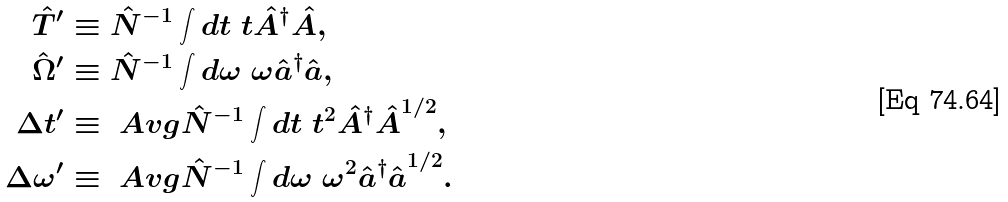<formula> <loc_0><loc_0><loc_500><loc_500>\hat { T } ^ { \prime } & \equiv \hat { N } ^ { - 1 } \int d t \ t \hat { A } ^ { \dagger } \hat { A } , \\ \hat { \Omega } ^ { \prime } & \equiv \hat { N } ^ { - 1 } \int d \omega \ \omega \hat { a } ^ { \dagger } \hat { a } , \\ \Delta t ^ { \prime } & \equiv \ A v g { \hat { N } ^ { - 1 } \int d t \ t ^ { 2 } \hat { A } ^ { \dagger } \hat { A } } ^ { 1 / 2 } , \\ \Delta \omega ^ { \prime } & \equiv \ A v g { \hat { N } ^ { - 1 } \int d \omega \ \omega ^ { 2 } \hat { a } ^ { \dagger } \hat { a } } ^ { 1 / 2 } .</formula> 